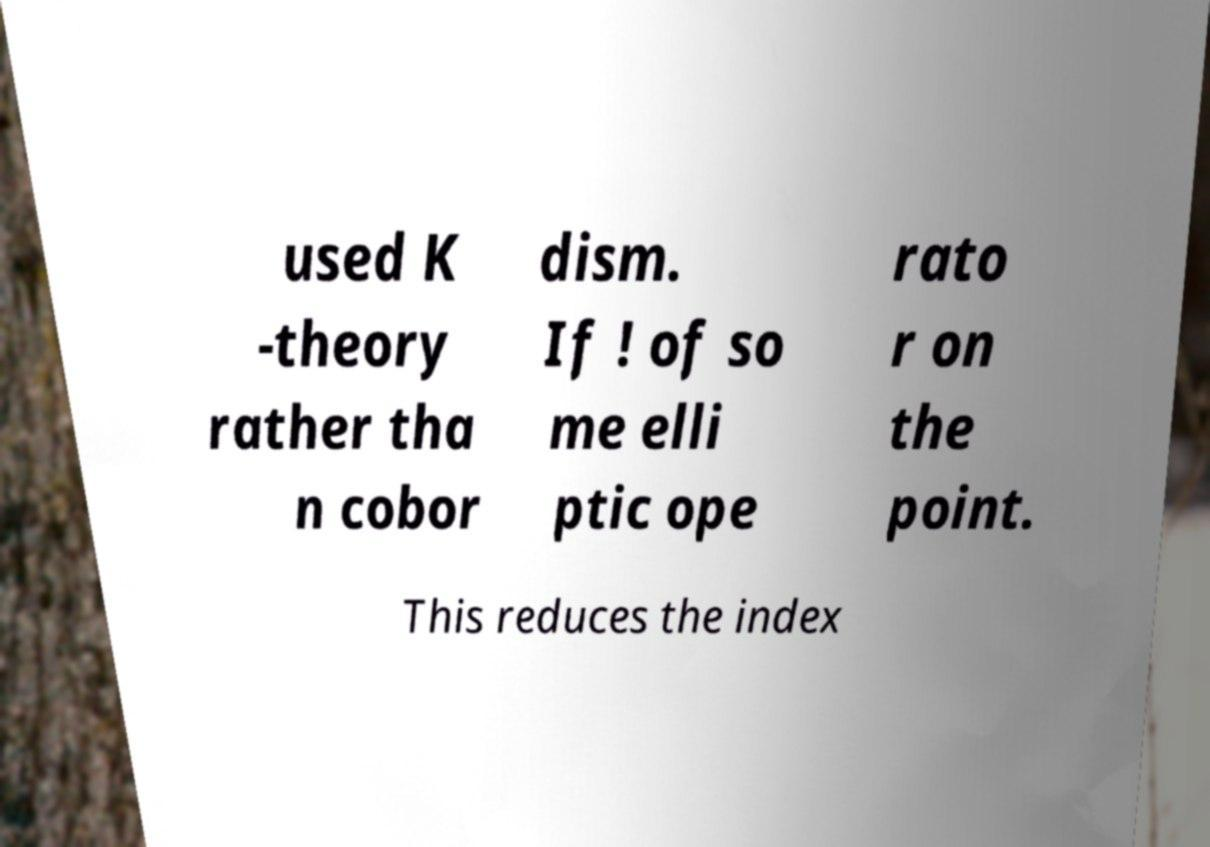There's text embedded in this image that I need extracted. Can you transcribe it verbatim? used K -theory rather tha n cobor dism. If ! of so me elli ptic ope rato r on the point. This reduces the index 